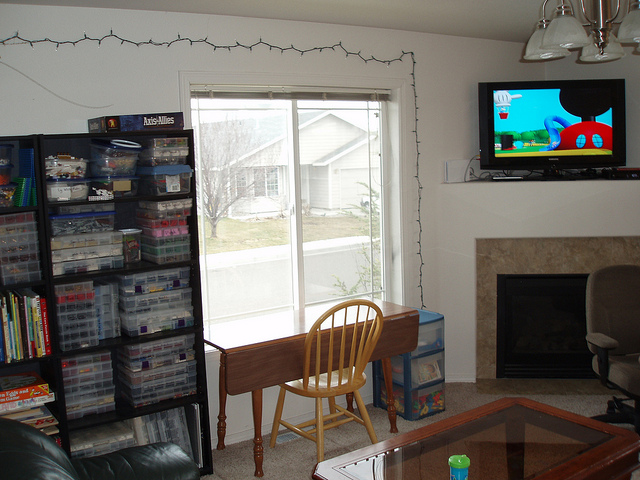Please identify all text content in this image. AXIS ALLIES 